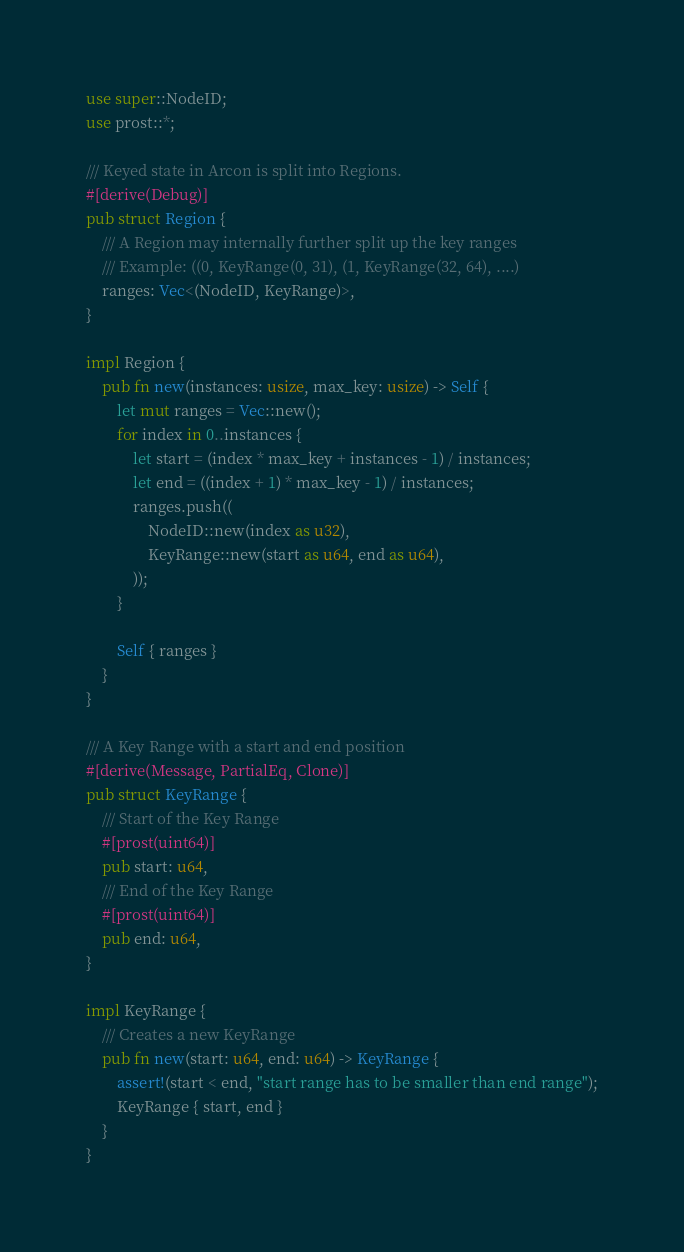Convert code to text. <code><loc_0><loc_0><loc_500><loc_500><_Rust_>use super::NodeID;
use prost::*;

/// Keyed state in Arcon is split into Regions.
#[derive(Debug)]
pub struct Region {
    /// A Region may internally further split up the key ranges
    /// Example: ((0, KeyRange(0, 31), (1, KeyRange(32, 64), ....)
    ranges: Vec<(NodeID, KeyRange)>,
}

impl Region {
    pub fn new(instances: usize, max_key: usize) -> Self {
        let mut ranges = Vec::new();
        for index in 0..instances {
            let start = (index * max_key + instances - 1) / instances;
            let end = ((index + 1) * max_key - 1) / instances;
            ranges.push((
                NodeID::new(index as u32),
                KeyRange::new(start as u64, end as u64),
            ));
        }

        Self { ranges }
    }
}

/// A Key Range with a start and end position
#[derive(Message, PartialEq, Clone)]
pub struct KeyRange {
    /// Start of the Key Range
    #[prost(uint64)]
    pub start: u64,
    /// End of the Key Range
    #[prost(uint64)]
    pub end: u64,
}

impl KeyRange {
    /// Creates a new KeyRange
    pub fn new(start: u64, end: u64) -> KeyRange {
        assert!(start < end, "start range has to be smaller than end range");
        KeyRange { start, end }
    }
}
</code> 